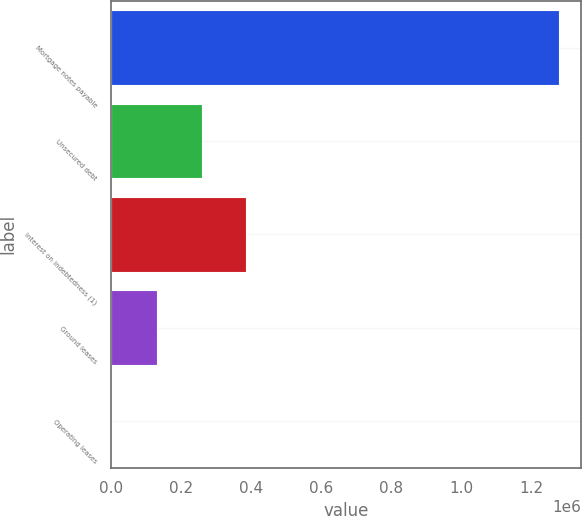<chart> <loc_0><loc_0><loc_500><loc_500><bar_chart><fcel>Mortgage notes payable<fcel>Unsecured debt<fcel>Interest on indebtedness (1)<fcel>Ground leases<fcel>Operating leases<nl><fcel>1.2793e+06<fcel>258894<fcel>386444<fcel>131343<fcel>3792<nl></chart> 